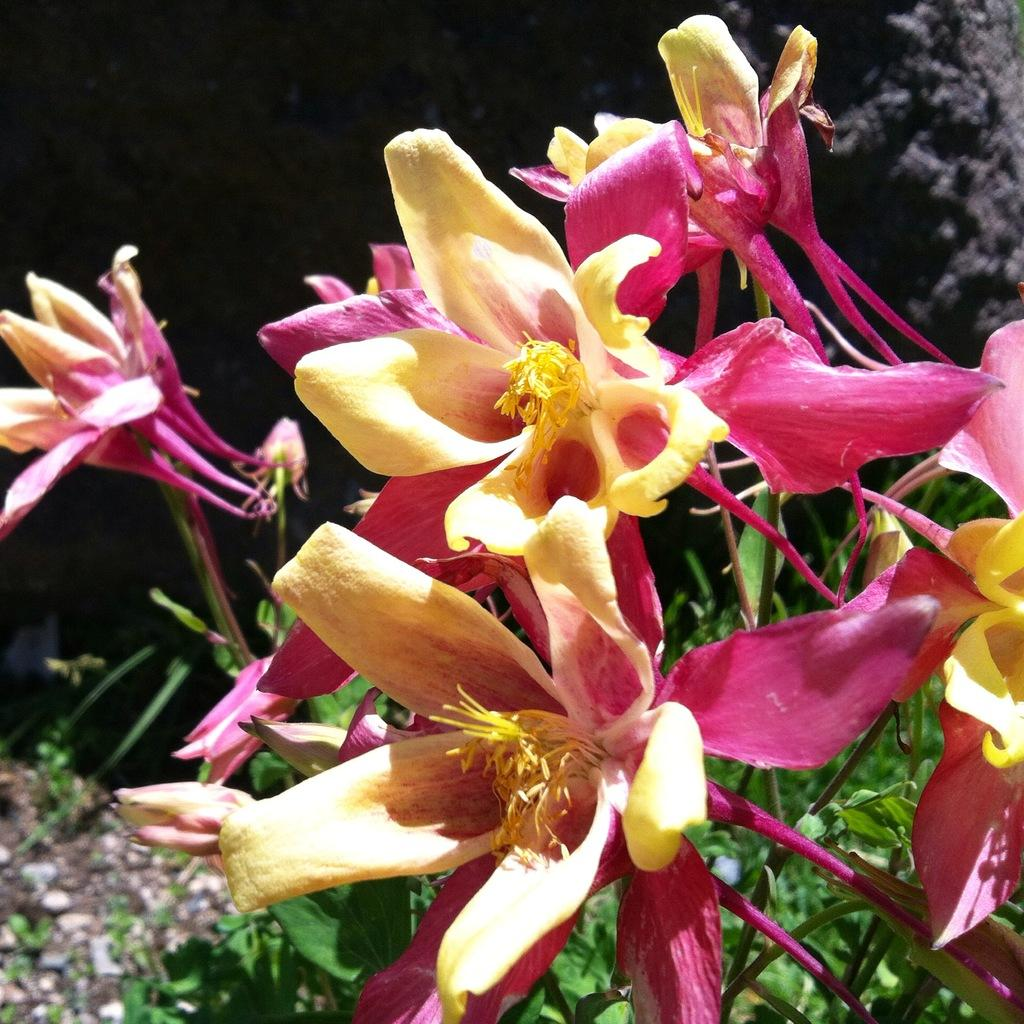What type of flowers can be seen in the image? There are red and yellow colorful flowers in the image. What can be seen in the background of the image? There are trees and plants in the background of the image. How many bikes are parked next to the flowers in the image? There are no bikes present in the image; it only features flowers, trees, and plants. 